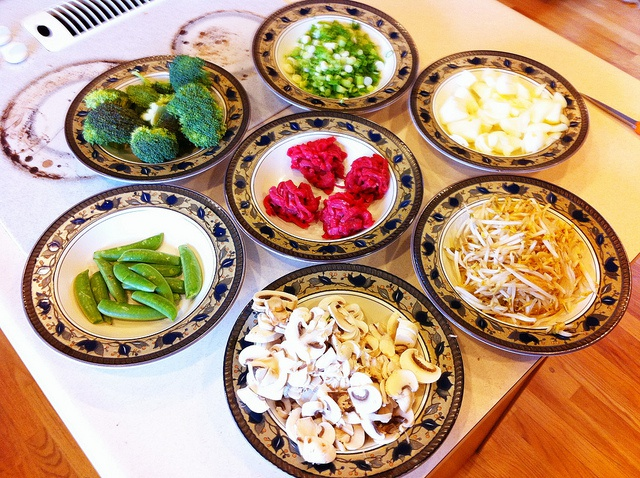Describe the objects in this image and their specific colors. I can see bowl in pink, white, tan, black, and olive tones, bowl in pink, lavender, brown, and black tones, bowl in pink, black, olive, maroon, and teal tones, bowl in pink, ivory, khaki, maroon, and tan tones, and bowl in pink, lavender, lightpink, and maroon tones in this image. 